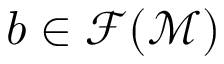<formula> <loc_0><loc_0><loc_500><loc_500>b \in \mathcal { F } ( \mathcal { M } )</formula> 